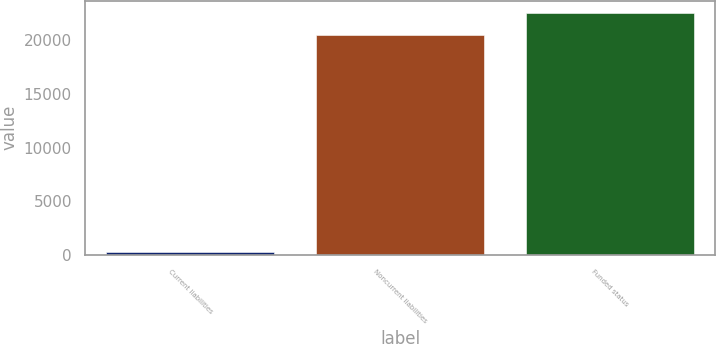<chart> <loc_0><loc_0><loc_500><loc_500><bar_chart><fcel>Current liabilities<fcel>Noncurrent liabilities<fcel>Funded status<nl><fcel>260<fcel>20508<fcel>22558.8<nl></chart> 